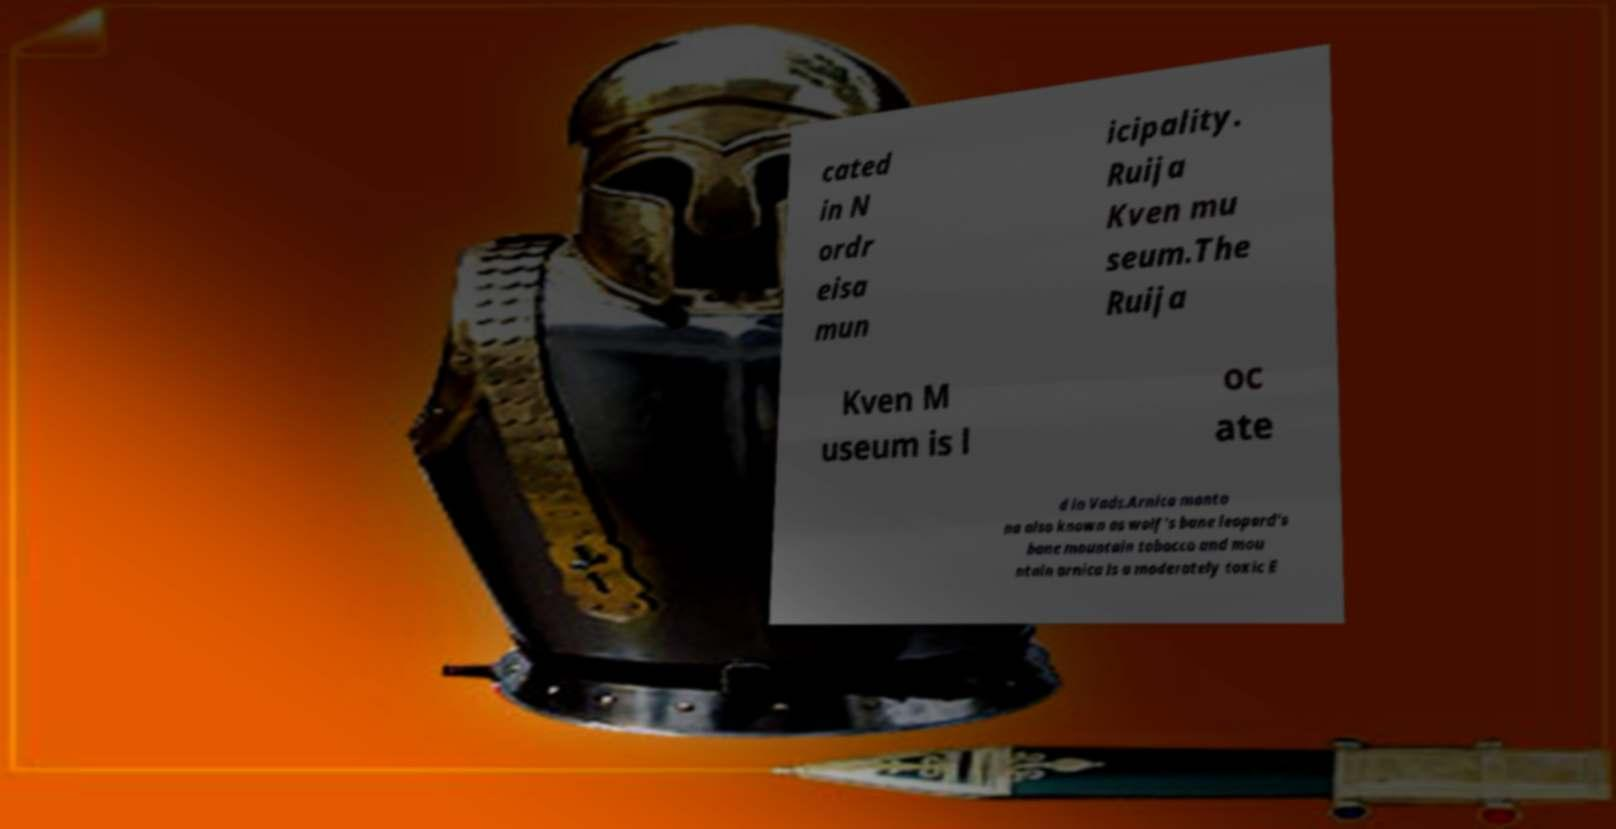Could you extract and type out the text from this image? cated in N ordr eisa mun icipality. Ruija Kven mu seum.The Ruija Kven M useum is l oc ate d in Vads.Arnica monta na also known as wolf's bane leopard's bane mountain tobacco and mou ntain arnica is a moderately toxic E 